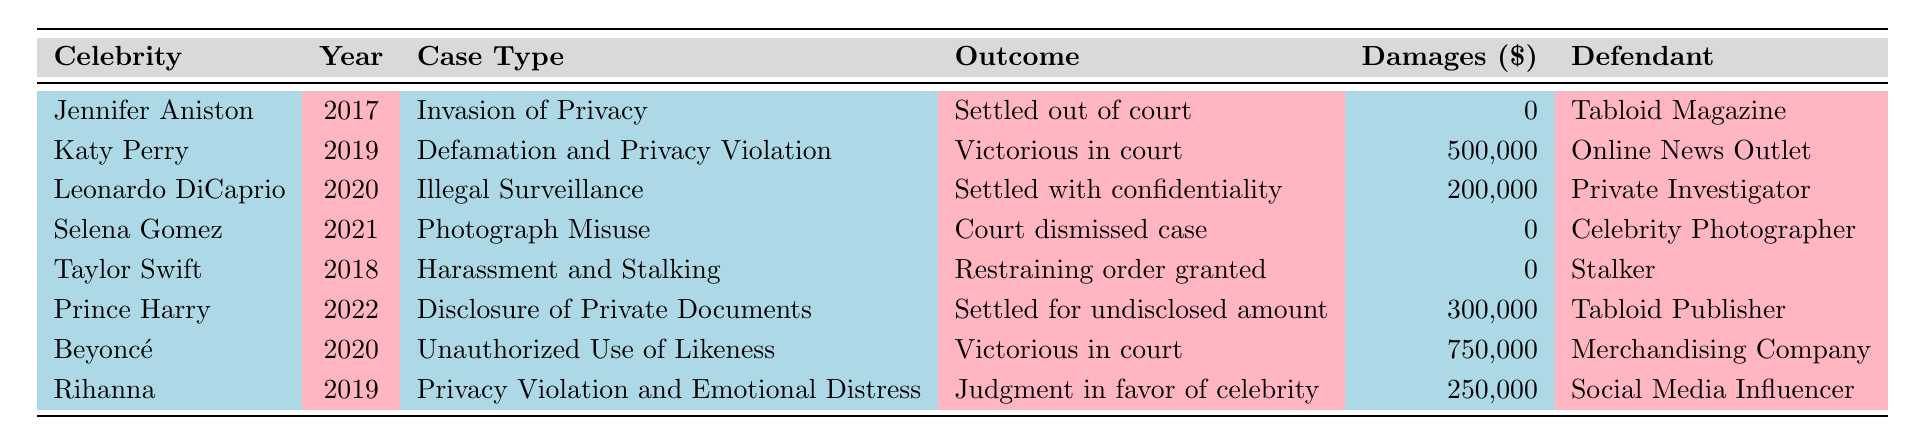What was the outcome of Katy Perry's lawsuit? According to the table, Katy Perry's lawsuit outcome is listed as "Victorious in court."
Answer: Victorious in court How much were the damages awarded to Beyoncé? The table shows that Beyoncé was awarded damages of $750,000.
Answer: 750,000 Did Taylor Swift win her case? The table indicates that Taylor Swift received a "Restraining order granted," which implies she did not necessarily win in the traditional sense of a monetary award but received a legal protection. So, the answer is no.
Answer: No What was the total amount of damages awarded across all lawsuits? The damages awarded for each lawsuit are $0 (Jennifer Aniston), $500,000 (Katy Perry), $200,000 (Leonardo DiCaprio), $0 (Selena Gomez), $0 (Taylor Swift), $300,000 (Prince Harry), $750,000 (Beyoncé), and $250,000 (Rihanna). Summing these gives 0 + 500,000 + 200,000 + 0 + 0 + 300,000 + 750,000 + 250,000 = 2,000,000.
Answer: 2,000,000 Which celebrity had their case dismissed? The table shows that Selena Gomez's case outcome was "Court dismissed case."
Answer: Selena Gomez Was there any case that resulted in no damages awarded? The table indicates that Jennifer Aniston, Selena Gomez, and Taylor Swift all had a damages awarded amount of $0, confirming multiple instances of cases with no damages.
Answer: Yes Which celebrity received the highest damages awarded? Reviewing the table, examining the damages awarded: Katy Perry ($500,000), Leonardo DiCaprio ($200,000), Prince Harry ($300,000), Beyoncé ($750,000), and Rihanna ($250,000). The highest value is for Beyoncé with $750,000.
Answer: Beyoncé How many lawsuits involved a tabloid as the defendant? The table reveals that there are two cases involving tabloids: Jennifer Aniston (Tabloid Magazine) and Prince Harry (Tabloid Publisher). Therefore, there are two instances.
Answer: 2 What was the type of case for Rihanna? According to the table, Rihanna's case type is listed as "Privacy Violation and Emotional Distress."
Answer: Privacy Violation and Emotional Distress 